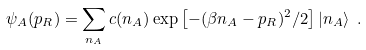Convert formula to latex. <formula><loc_0><loc_0><loc_500><loc_500>\psi _ { A } ( p _ { R } ) = \sum _ { n _ { A } } c ( n _ { A } ) \exp \left [ - ( \beta n _ { A } - p _ { R } ) ^ { 2 } / { 2 } \right ] | n _ { A } \rangle \ .</formula> 